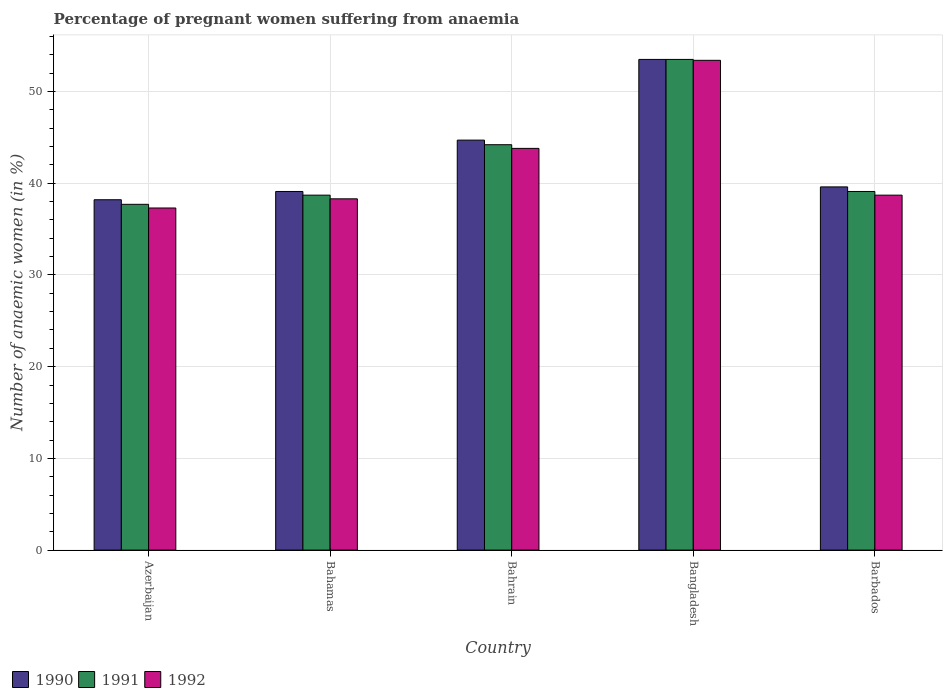Are the number of bars on each tick of the X-axis equal?
Your answer should be very brief. Yes. How many bars are there on the 2nd tick from the left?
Provide a short and direct response. 3. How many bars are there on the 3rd tick from the right?
Provide a short and direct response. 3. What is the label of the 2nd group of bars from the left?
Make the answer very short. Bahamas. What is the number of anaemic women in 1992 in Bangladesh?
Offer a very short reply. 53.4. Across all countries, what is the maximum number of anaemic women in 1992?
Make the answer very short. 53.4. Across all countries, what is the minimum number of anaemic women in 1990?
Your answer should be compact. 38.2. In which country was the number of anaemic women in 1992 maximum?
Your response must be concise. Bangladesh. In which country was the number of anaemic women in 1991 minimum?
Your answer should be compact. Azerbaijan. What is the total number of anaemic women in 1991 in the graph?
Provide a short and direct response. 213.2. What is the difference between the number of anaemic women in 1991 in Bahrain and the number of anaemic women in 1992 in Bangladesh?
Ensure brevity in your answer.  -9.2. What is the average number of anaemic women in 1990 per country?
Offer a very short reply. 43.02. What is the difference between the number of anaemic women of/in 1992 and number of anaemic women of/in 1991 in Bangladesh?
Provide a short and direct response. -0.1. What is the ratio of the number of anaemic women in 1992 in Azerbaijan to that in Bahamas?
Offer a very short reply. 0.97. Is the difference between the number of anaemic women in 1992 in Azerbaijan and Bahamas greater than the difference between the number of anaemic women in 1991 in Azerbaijan and Bahamas?
Provide a short and direct response. No. What is the difference between the highest and the second highest number of anaemic women in 1991?
Ensure brevity in your answer.  -9.3. What is the difference between the highest and the lowest number of anaemic women in 1990?
Provide a short and direct response. 15.3. What does the 3rd bar from the right in Bangladesh represents?
Your answer should be very brief. 1990. Is it the case that in every country, the sum of the number of anaemic women in 1991 and number of anaemic women in 1990 is greater than the number of anaemic women in 1992?
Provide a short and direct response. Yes. How many countries are there in the graph?
Provide a short and direct response. 5. What is the difference between two consecutive major ticks on the Y-axis?
Provide a succinct answer. 10. Does the graph contain any zero values?
Your response must be concise. No. Where does the legend appear in the graph?
Your response must be concise. Bottom left. How are the legend labels stacked?
Make the answer very short. Horizontal. What is the title of the graph?
Ensure brevity in your answer.  Percentage of pregnant women suffering from anaemia. What is the label or title of the Y-axis?
Provide a short and direct response. Number of anaemic women (in %). What is the Number of anaemic women (in %) of 1990 in Azerbaijan?
Offer a very short reply. 38.2. What is the Number of anaemic women (in %) of 1991 in Azerbaijan?
Give a very brief answer. 37.7. What is the Number of anaemic women (in %) of 1992 in Azerbaijan?
Provide a succinct answer. 37.3. What is the Number of anaemic women (in %) in 1990 in Bahamas?
Offer a terse response. 39.1. What is the Number of anaemic women (in %) in 1991 in Bahamas?
Offer a very short reply. 38.7. What is the Number of anaemic women (in %) of 1992 in Bahamas?
Ensure brevity in your answer.  38.3. What is the Number of anaemic women (in %) of 1990 in Bahrain?
Keep it short and to the point. 44.7. What is the Number of anaemic women (in %) in 1991 in Bahrain?
Your response must be concise. 44.2. What is the Number of anaemic women (in %) of 1992 in Bahrain?
Your answer should be very brief. 43.8. What is the Number of anaemic women (in %) in 1990 in Bangladesh?
Your response must be concise. 53.5. What is the Number of anaemic women (in %) in 1991 in Bangladesh?
Provide a succinct answer. 53.5. What is the Number of anaemic women (in %) of 1992 in Bangladesh?
Keep it short and to the point. 53.4. What is the Number of anaemic women (in %) of 1990 in Barbados?
Offer a terse response. 39.6. What is the Number of anaemic women (in %) of 1991 in Barbados?
Offer a terse response. 39.1. What is the Number of anaemic women (in %) in 1992 in Barbados?
Provide a succinct answer. 38.7. Across all countries, what is the maximum Number of anaemic women (in %) of 1990?
Provide a short and direct response. 53.5. Across all countries, what is the maximum Number of anaemic women (in %) of 1991?
Make the answer very short. 53.5. Across all countries, what is the maximum Number of anaemic women (in %) of 1992?
Your response must be concise. 53.4. Across all countries, what is the minimum Number of anaemic women (in %) in 1990?
Your answer should be very brief. 38.2. Across all countries, what is the minimum Number of anaemic women (in %) in 1991?
Your answer should be very brief. 37.7. Across all countries, what is the minimum Number of anaemic women (in %) in 1992?
Keep it short and to the point. 37.3. What is the total Number of anaemic women (in %) in 1990 in the graph?
Give a very brief answer. 215.1. What is the total Number of anaemic women (in %) in 1991 in the graph?
Offer a terse response. 213.2. What is the total Number of anaemic women (in %) of 1992 in the graph?
Provide a succinct answer. 211.5. What is the difference between the Number of anaemic women (in %) in 1990 in Azerbaijan and that in Bahamas?
Make the answer very short. -0.9. What is the difference between the Number of anaemic women (in %) in 1990 in Azerbaijan and that in Bahrain?
Your answer should be very brief. -6.5. What is the difference between the Number of anaemic women (in %) of 1991 in Azerbaijan and that in Bahrain?
Your answer should be very brief. -6.5. What is the difference between the Number of anaemic women (in %) of 1992 in Azerbaijan and that in Bahrain?
Offer a terse response. -6.5. What is the difference between the Number of anaemic women (in %) in 1990 in Azerbaijan and that in Bangladesh?
Offer a terse response. -15.3. What is the difference between the Number of anaemic women (in %) in 1991 in Azerbaijan and that in Bangladesh?
Offer a terse response. -15.8. What is the difference between the Number of anaemic women (in %) in 1992 in Azerbaijan and that in Bangladesh?
Offer a terse response. -16.1. What is the difference between the Number of anaemic women (in %) in 1991 in Bahamas and that in Bahrain?
Ensure brevity in your answer.  -5.5. What is the difference between the Number of anaemic women (in %) of 1990 in Bahamas and that in Bangladesh?
Offer a very short reply. -14.4. What is the difference between the Number of anaemic women (in %) in 1991 in Bahamas and that in Bangladesh?
Provide a succinct answer. -14.8. What is the difference between the Number of anaemic women (in %) of 1992 in Bahamas and that in Bangladesh?
Give a very brief answer. -15.1. What is the difference between the Number of anaemic women (in %) of 1991 in Bahamas and that in Barbados?
Your answer should be compact. -0.4. What is the difference between the Number of anaemic women (in %) in 1991 in Bahrain and that in Bangladesh?
Your answer should be very brief. -9.3. What is the difference between the Number of anaemic women (in %) in 1990 in Bahrain and that in Barbados?
Make the answer very short. 5.1. What is the difference between the Number of anaemic women (in %) of 1990 in Bangladesh and that in Barbados?
Offer a very short reply. 13.9. What is the difference between the Number of anaemic women (in %) of 1992 in Bangladesh and that in Barbados?
Provide a succinct answer. 14.7. What is the difference between the Number of anaemic women (in %) in 1991 in Azerbaijan and the Number of anaemic women (in %) in 1992 in Bahamas?
Ensure brevity in your answer.  -0.6. What is the difference between the Number of anaemic women (in %) of 1990 in Azerbaijan and the Number of anaemic women (in %) of 1991 in Bahrain?
Your response must be concise. -6. What is the difference between the Number of anaemic women (in %) in 1990 in Azerbaijan and the Number of anaemic women (in %) in 1992 in Bahrain?
Give a very brief answer. -5.6. What is the difference between the Number of anaemic women (in %) of 1990 in Azerbaijan and the Number of anaemic women (in %) of 1991 in Bangladesh?
Make the answer very short. -15.3. What is the difference between the Number of anaemic women (in %) in 1990 in Azerbaijan and the Number of anaemic women (in %) in 1992 in Bangladesh?
Your answer should be compact. -15.2. What is the difference between the Number of anaemic women (in %) in 1991 in Azerbaijan and the Number of anaemic women (in %) in 1992 in Bangladesh?
Your answer should be compact. -15.7. What is the difference between the Number of anaemic women (in %) in 1991 in Azerbaijan and the Number of anaemic women (in %) in 1992 in Barbados?
Your answer should be compact. -1. What is the difference between the Number of anaemic women (in %) in 1990 in Bahamas and the Number of anaemic women (in %) in 1992 in Bahrain?
Ensure brevity in your answer.  -4.7. What is the difference between the Number of anaemic women (in %) of 1991 in Bahamas and the Number of anaemic women (in %) of 1992 in Bahrain?
Offer a very short reply. -5.1. What is the difference between the Number of anaemic women (in %) of 1990 in Bahamas and the Number of anaemic women (in %) of 1991 in Bangladesh?
Provide a succinct answer. -14.4. What is the difference between the Number of anaemic women (in %) in 1990 in Bahamas and the Number of anaemic women (in %) in 1992 in Bangladesh?
Provide a short and direct response. -14.3. What is the difference between the Number of anaemic women (in %) of 1991 in Bahamas and the Number of anaemic women (in %) of 1992 in Bangladesh?
Keep it short and to the point. -14.7. What is the difference between the Number of anaemic women (in %) in 1990 in Bahrain and the Number of anaemic women (in %) in 1992 in Barbados?
Give a very brief answer. 6. What is the difference between the Number of anaemic women (in %) of 1991 in Bahrain and the Number of anaemic women (in %) of 1992 in Barbados?
Your answer should be very brief. 5.5. What is the difference between the Number of anaemic women (in %) of 1990 in Bangladesh and the Number of anaemic women (in %) of 1991 in Barbados?
Offer a very short reply. 14.4. What is the average Number of anaemic women (in %) of 1990 per country?
Your answer should be very brief. 43.02. What is the average Number of anaemic women (in %) of 1991 per country?
Ensure brevity in your answer.  42.64. What is the average Number of anaemic women (in %) of 1992 per country?
Your response must be concise. 42.3. What is the difference between the Number of anaemic women (in %) in 1991 and Number of anaemic women (in %) in 1992 in Azerbaijan?
Offer a terse response. 0.4. What is the difference between the Number of anaemic women (in %) of 1991 and Number of anaemic women (in %) of 1992 in Bahamas?
Make the answer very short. 0.4. What is the difference between the Number of anaemic women (in %) of 1990 and Number of anaemic women (in %) of 1992 in Bahrain?
Offer a very short reply. 0.9. What is the difference between the Number of anaemic women (in %) of 1990 and Number of anaemic women (in %) of 1991 in Bangladesh?
Offer a very short reply. 0. What is the difference between the Number of anaemic women (in %) of 1991 and Number of anaemic women (in %) of 1992 in Bangladesh?
Keep it short and to the point. 0.1. What is the difference between the Number of anaemic women (in %) of 1990 and Number of anaemic women (in %) of 1992 in Barbados?
Ensure brevity in your answer.  0.9. What is the difference between the Number of anaemic women (in %) of 1991 and Number of anaemic women (in %) of 1992 in Barbados?
Make the answer very short. 0.4. What is the ratio of the Number of anaemic women (in %) of 1991 in Azerbaijan to that in Bahamas?
Provide a short and direct response. 0.97. What is the ratio of the Number of anaemic women (in %) in 1992 in Azerbaijan to that in Bahamas?
Provide a short and direct response. 0.97. What is the ratio of the Number of anaemic women (in %) in 1990 in Azerbaijan to that in Bahrain?
Ensure brevity in your answer.  0.85. What is the ratio of the Number of anaemic women (in %) of 1991 in Azerbaijan to that in Bahrain?
Make the answer very short. 0.85. What is the ratio of the Number of anaemic women (in %) in 1992 in Azerbaijan to that in Bahrain?
Offer a terse response. 0.85. What is the ratio of the Number of anaemic women (in %) in 1990 in Azerbaijan to that in Bangladesh?
Keep it short and to the point. 0.71. What is the ratio of the Number of anaemic women (in %) of 1991 in Azerbaijan to that in Bangladesh?
Your answer should be compact. 0.7. What is the ratio of the Number of anaemic women (in %) in 1992 in Azerbaijan to that in Bangladesh?
Make the answer very short. 0.7. What is the ratio of the Number of anaemic women (in %) in 1990 in Azerbaijan to that in Barbados?
Give a very brief answer. 0.96. What is the ratio of the Number of anaemic women (in %) of 1991 in Azerbaijan to that in Barbados?
Your answer should be very brief. 0.96. What is the ratio of the Number of anaemic women (in %) of 1992 in Azerbaijan to that in Barbados?
Keep it short and to the point. 0.96. What is the ratio of the Number of anaemic women (in %) in 1990 in Bahamas to that in Bahrain?
Offer a very short reply. 0.87. What is the ratio of the Number of anaemic women (in %) of 1991 in Bahamas to that in Bahrain?
Your answer should be very brief. 0.88. What is the ratio of the Number of anaemic women (in %) in 1992 in Bahamas to that in Bahrain?
Your answer should be compact. 0.87. What is the ratio of the Number of anaemic women (in %) in 1990 in Bahamas to that in Bangladesh?
Give a very brief answer. 0.73. What is the ratio of the Number of anaemic women (in %) of 1991 in Bahamas to that in Bangladesh?
Offer a very short reply. 0.72. What is the ratio of the Number of anaemic women (in %) of 1992 in Bahamas to that in Bangladesh?
Give a very brief answer. 0.72. What is the ratio of the Number of anaemic women (in %) of 1990 in Bahamas to that in Barbados?
Give a very brief answer. 0.99. What is the ratio of the Number of anaemic women (in %) in 1992 in Bahamas to that in Barbados?
Your answer should be compact. 0.99. What is the ratio of the Number of anaemic women (in %) in 1990 in Bahrain to that in Bangladesh?
Provide a succinct answer. 0.84. What is the ratio of the Number of anaemic women (in %) of 1991 in Bahrain to that in Bangladesh?
Keep it short and to the point. 0.83. What is the ratio of the Number of anaemic women (in %) in 1992 in Bahrain to that in Bangladesh?
Your response must be concise. 0.82. What is the ratio of the Number of anaemic women (in %) in 1990 in Bahrain to that in Barbados?
Make the answer very short. 1.13. What is the ratio of the Number of anaemic women (in %) of 1991 in Bahrain to that in Barbados?
Offer a very short reply. 1.13. What is the ratio of the Number of anaemic women (in %) of 1992 in Bahrain to that in Barbados?
Offer a very short reply. 1.13. What is the ratio of the Number of anaemic women (in %) in 1990 in Bangladesh to that in Barbados?
Provide a succinct answer. 1.35. What is the ratio of the Number of anaemic women (in %) of 1991 in Bangladesh to that in Barbados?
Provide a succinct answer. 1.37. What is the ratio of the Number of anaemic women (in %) of 1992 in Bangladesh to that in Barbados?
Make the answer very short. 1.38. What is the difference between the highest and the second highest Number of anaemic women (in %) of 1990?
Your response must be concise. 8.8. What is the difference between the highest and the second highest Number of anaemic women (in %) of 1991?
Ensure brevity in your answer.  9.3. What is the difference between the highest and the lowest Number of anaemic women (in %) in 1991?
Your answer should be compact. 15.8. 